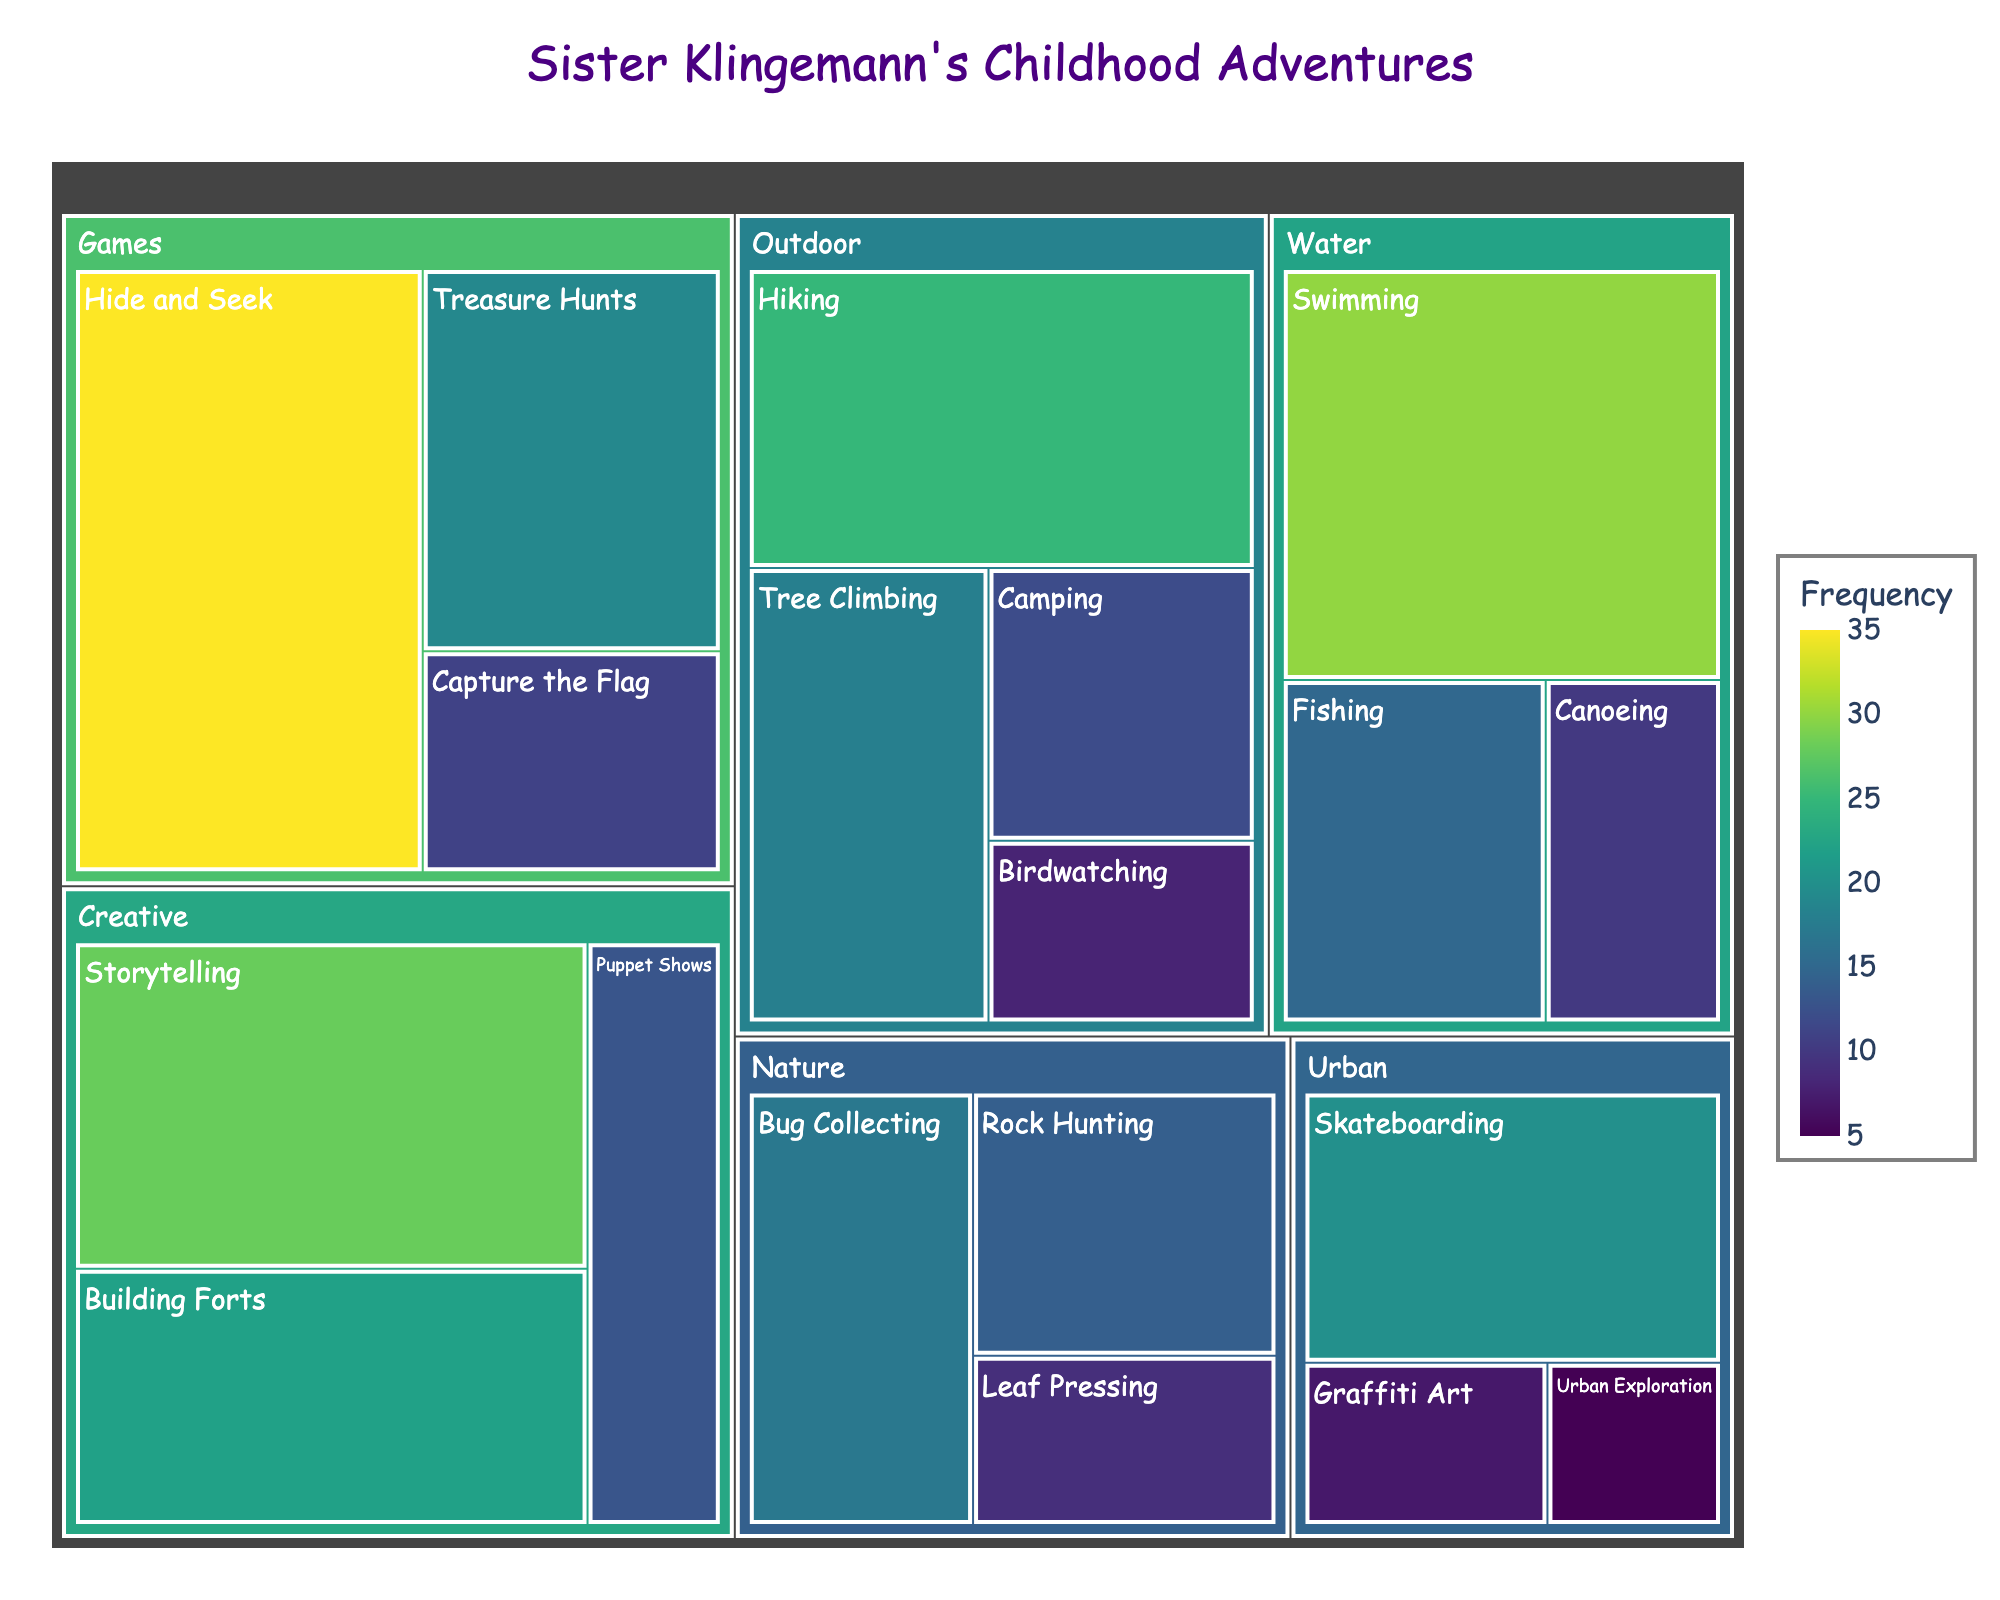What is the title of the treemap? The title is displayed at the top of the figure, usually in a larger font size and centered. In this case, it is easily identifiable.
Answer: Sister Klingemann's Childhood Adventures Which activity has the highest frequency? The activity with the highest frequency will have the largest area in the treemap. By examining the plot, you can identify the section with the largest area.
Answer: Hide and Seek How many activities are under the "Outdoor" category? Each category is a distinct section of the treemap, and the activities within each category are smaller sections. By counting the sections within the "Outdoor" category, we get the number of activities.
Answer: 4 Which category contains the activity "Bug Collecting"? To find this, you can visually follow the labels in the treemap. Each label is nested under its respective category.
Answer: Nature What is the total frequency of the "Water" activities? Sum the frequencies of all activities under the "Water" category: Swimming (30), Fishing (15), Canoeing (10). 30 + 15 + 10 = 55
Answer: 55 Out of the "Urban" activities, which one has the lowest frequency? By comparing the sizes of the sections within the "Urban" category, the smallest section represents the activity with the lowest frequency.
Answer: Urban Exploration What is the combined frequency of "Storytelling" and "Building Forts"? Add the frequencies of the two specified activities: Storytelling (28) and Building Forts (22). 28 + 22 = 50
Answer: 50 Which category has the most activities? Count the number of activities within each category and compare. The category with the highest count is the one with the most activities.
Answer: Games Compare the frequency of "Tree Climbing" and "Camping". Which is higher, and by how much? Subtract the frequency of "Camping" (12) from that of "Tree Climbing" (18). 18 - 12 = 6
Answer: Tree Climbing by 6 What color represents the highest frequency of activities, and which activity is that? The color intensity in the treemap increases with the frequency. The darkest color represents the highest frequency, which is associated with the largest section.
Answer: Dark green, Hide and Seek 